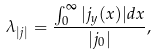Convert formula to latex. <formula><loc_0><loc_0><loc_500><loc_500>\lambda _ { | j | } = \frac { \int _ { 0 } ^ { \infty } | j _ { y } ( x ) | d x } { | j _ { 0 } | } ,</formula> 